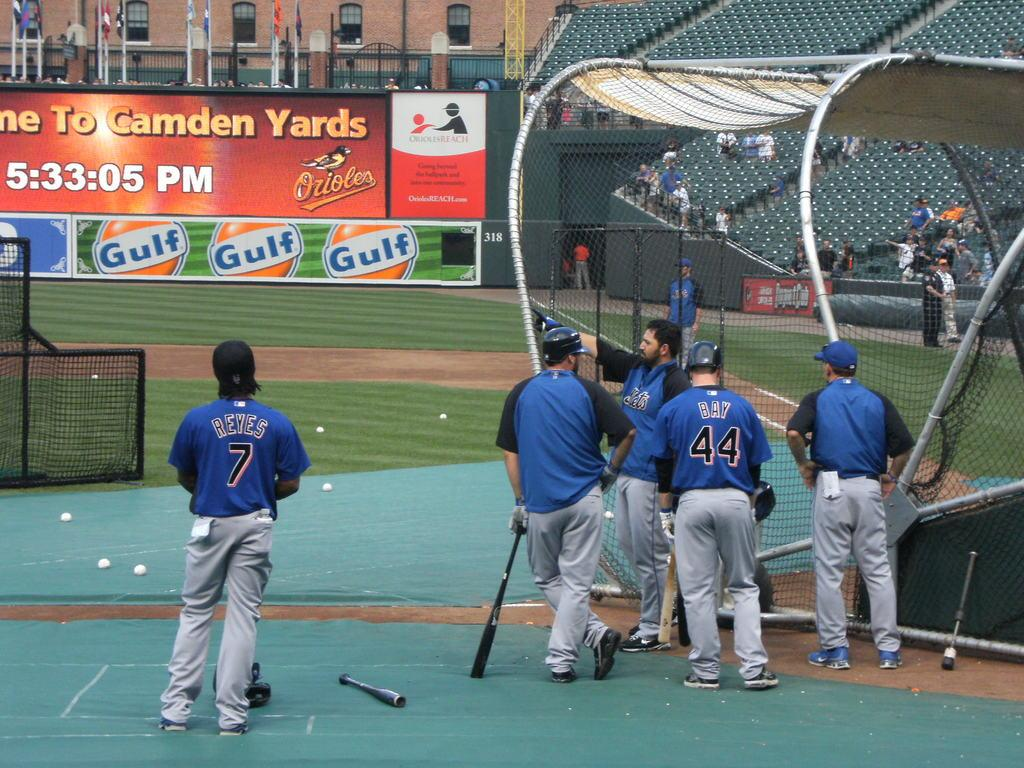<image>
Summarize the visual content of the image. Three Gulf Oil symbols decorate a wall inside a baseball stadium. 